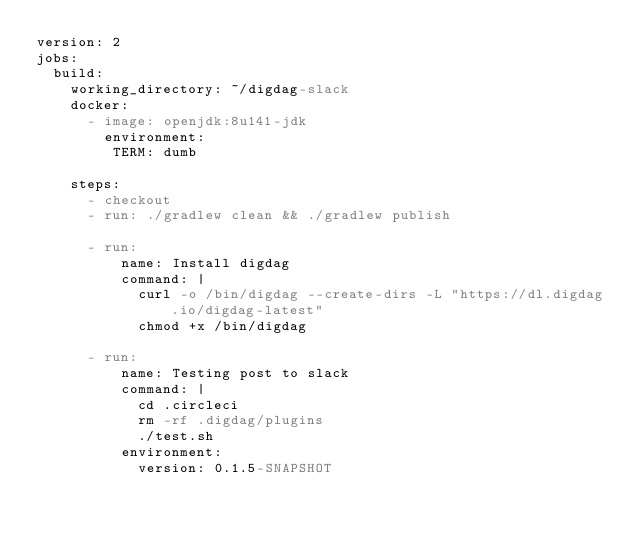<code> <loc_0><loc_0><loc_500><loc_500><_YAML_>version: 2
jobs:
  build:
    working_directory: ~/digdag-slack
    docker:
      - image: openjdk:8u141-jdk
        environment:
         TERM: dumb

    steps:
      - checkout
      - run: ./gradlew clean && ./gradlew publish

      - run:
          name: Install digdag
          command: |
            curl -o /bin/digdag --create-dirs -L "https://dl.digdag.io/digdag-latest"
            chmod +x /bin/digdag

      - run:
          name: Testing post to slack
          command: |
            cd .circleci
            rm -rf .digdag/plugins
            ./test.sh
          environment:
            version: 0.1.5-SNAPSHOT
</code> 